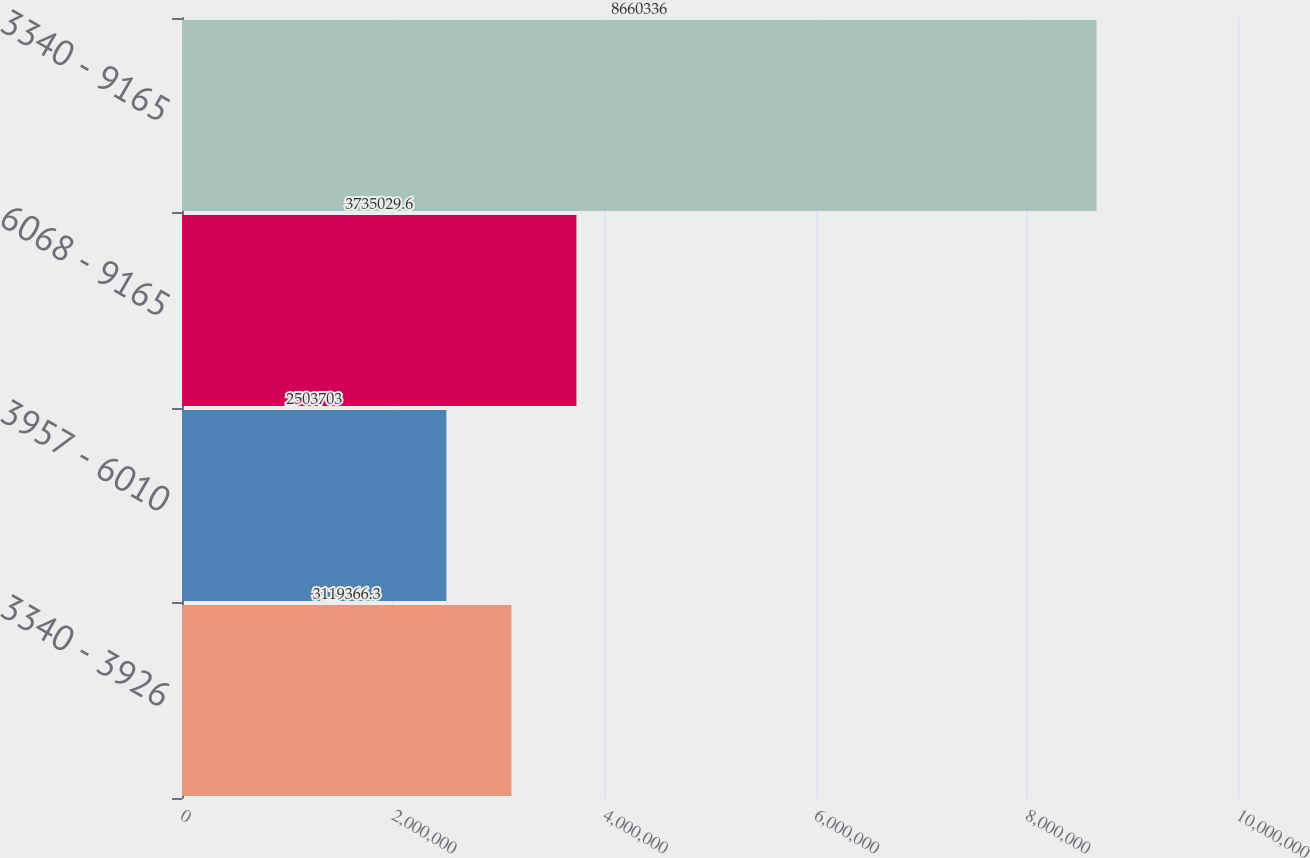Convert chart to OTSL. <chart><loc_0><loc_0><loc_500><loc_500><bar_chart><fcel>3340 - 3926<fcel>3957 - 6010<fcel>6068 - 9165<fcel>3340 - 9165<nl><fcel>3.11937e+06<fcel>2.5037e+06<fcel>3.73503e+06<fcel>8.66034e+06<nl></chart> 